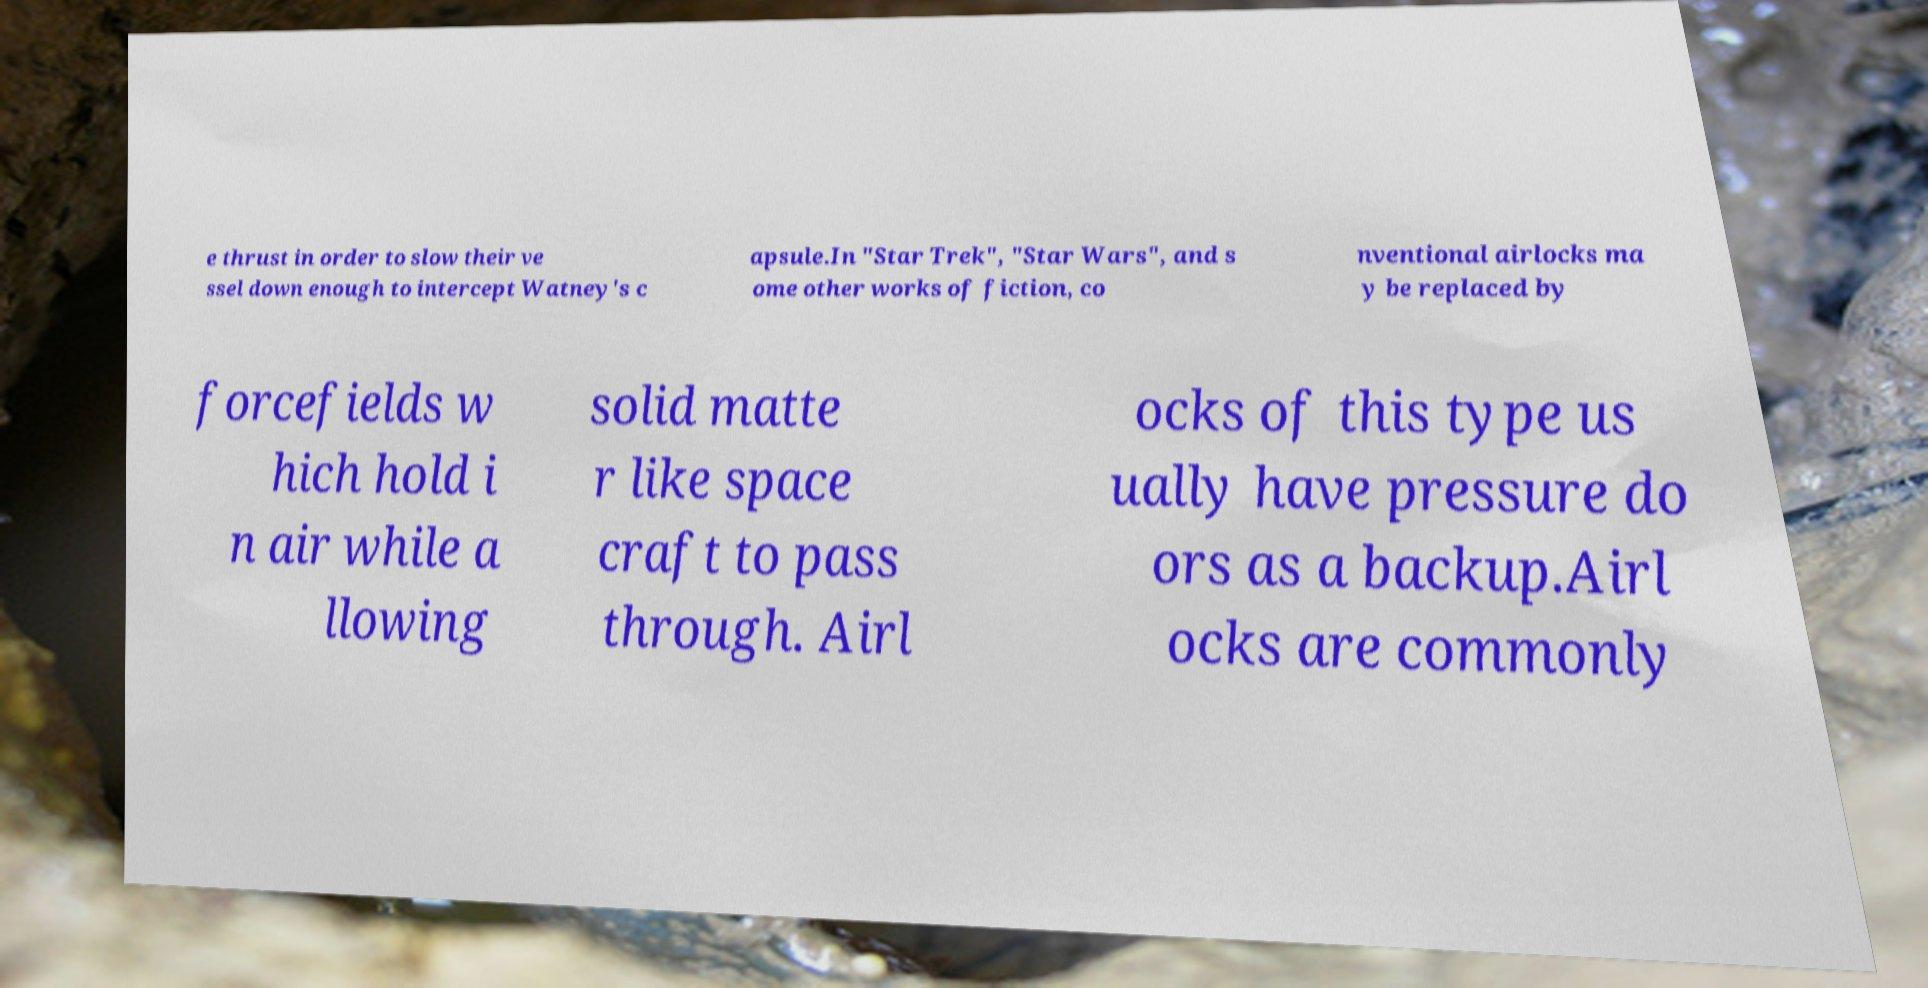Please identify and transcribe the text found in this image. e thrust in order to slow their ve ssel down enough to intercept Watney's c apsule.In "Star Trek", "Star Wars", and s ome other works of fiction, co nventional airlocks ma y be replaced by forcefields w hich hold i n air while a llowing solid matte r like space craft to pass through. Airl ocks of this type us ually have pressure do ors as a backup.Airl ocks are commonly 